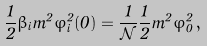<formula> <loc_0><loc_0><loc_500><loc_500>\frac { 1 } { 2 } \beta _ { i } m ^ { 2 } \varphi ^ { 2 } _ { i } ( 0 ) = \frac { 1 } { \mathcal { N } } \frac { 1 } { 2 } m ^ { 2 } \varphi ^ { 2 } _ { 0 } \, ,</formula> 